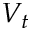<formula> <loc_0><loc_0><loc_500><loc_500>V _ { t }</formula> 